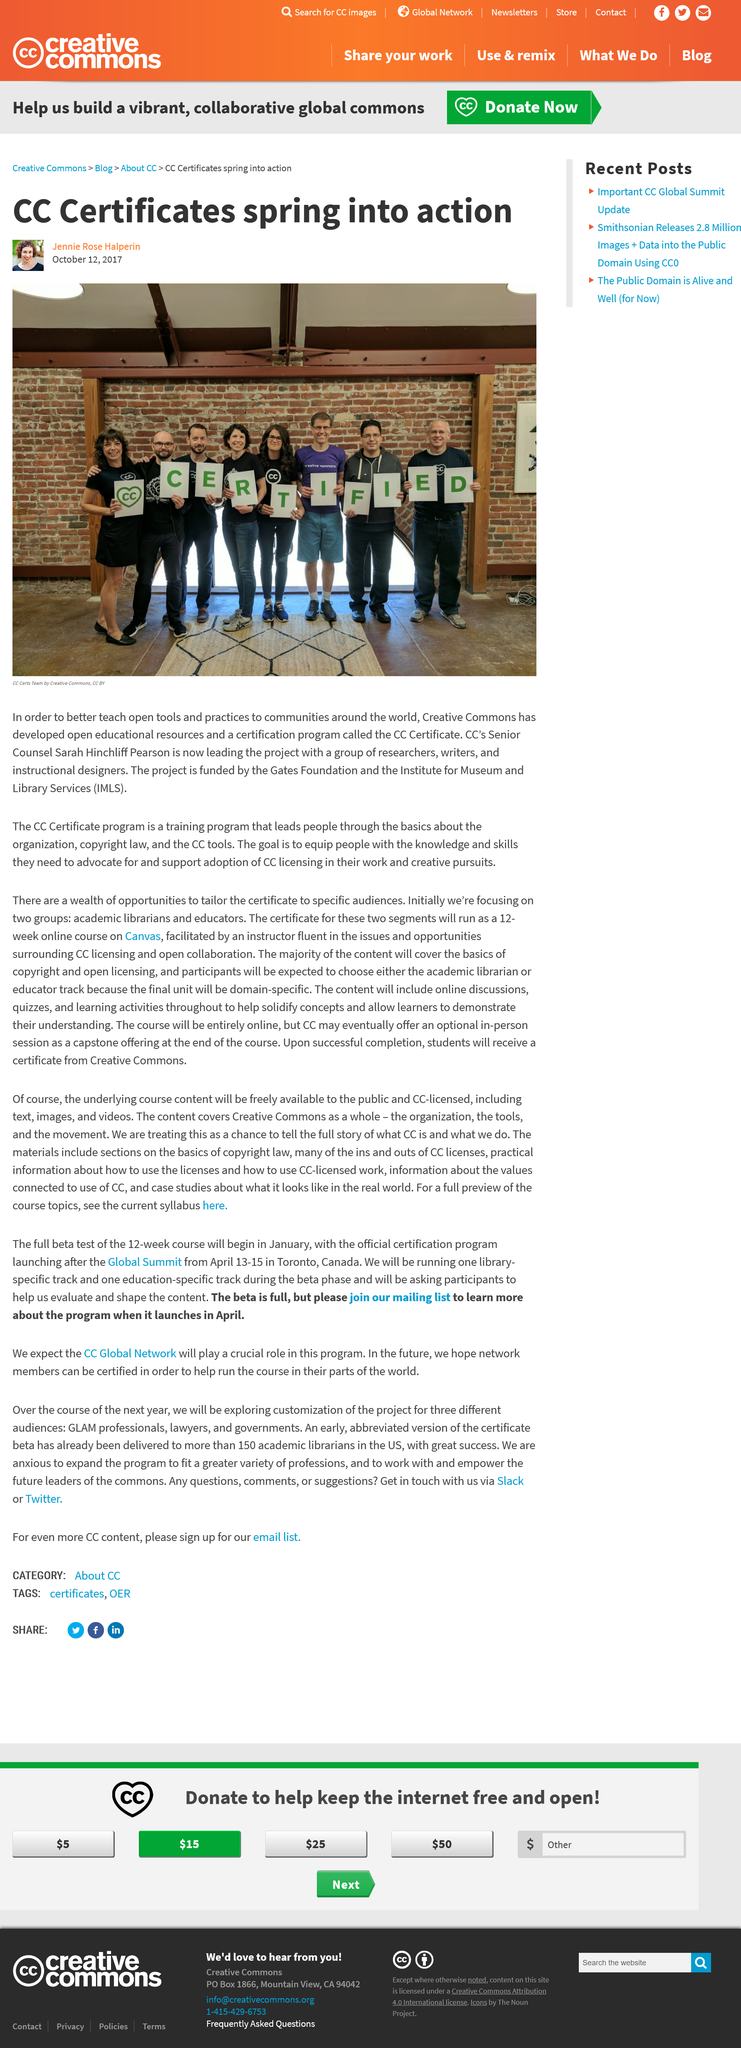Specify some key components in this picture. The Creative Commons Certificate Program is funded by the Gages Foundation and the Institute for Museum and Library Services (IMLS). The CC Certificate Program teaches individuals the fundamentals of Creative Commons, copyright law, and the utilization of CC tools to comprehend the organization's functioning and copyright regulations. Creative Commons has a certificate program called the CC Certificate, which is the name of the program. 